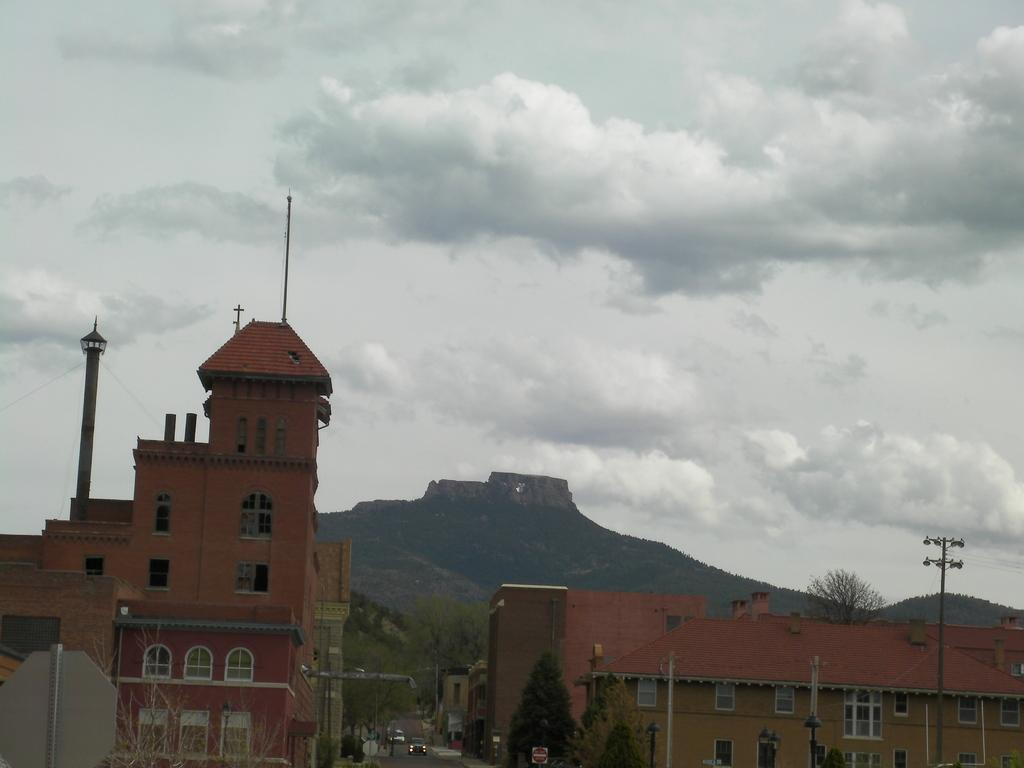What type of natural elements can be seen in the image? There are trees in the image. What type of man-made structures can be seen in the image? There are buildings in the image. Where are the trees and buildings located in the image? The trees and buildings are at the bottom of the image. What type of geographical feature is visible in the background of the image? There is a mountain in the background of the image. What is visible at the top of the image? The sky is visible at the top of the image. What is the condition of the sky in the image? The sky is cloudy in the image. How many fish can be seen swimming in the sky in the image? There are no fish visible in the sky in the image. What type of machine is present on the mountain in the image? There is no machine present on the mountain in the image. 